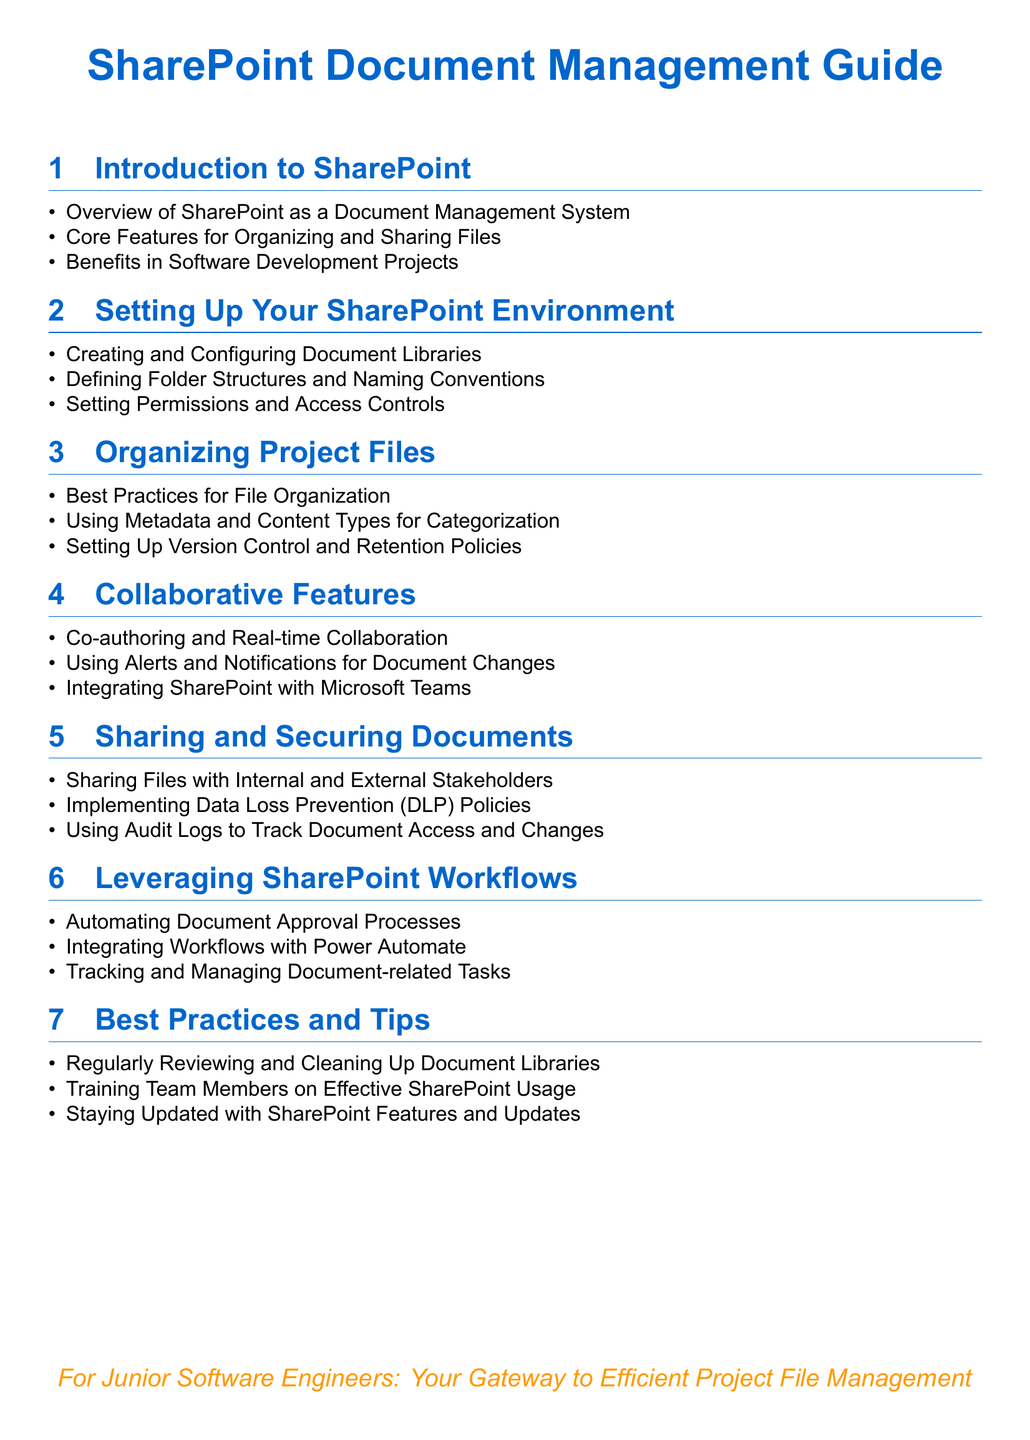What is the title of the document? The title is a central element and provides the subject of the document focused on SharePoint document management.
Answer: SharePoint Document Management Guide What is the core feature for organizing files? The document lists "Core Features for Organizing and Sharing Files" as a key point in the introduction section.
Answer: Core Features for Organizing and Sharing Files What is one benefit of SharePoint in software development projects? The introduction section highlights the advantages SharePoint brings specifically to software development projects.
Answer: Benefits in Software Development Projects What practice is recommended for file organization? The document provides guidance on best practices within the section dedicated to organizing project files.
Answer: Best Practices for File Organization Which tool can be integrated with SharePoint for automated workflows? The document mentions a specific tool that enhances workflow automation in the SharePoint workflow section.
Answer: Power Automate What is the purpose of implementing Data Loss Prevention policies? The document emphasizes the importance of security measures to protect data sharing with stakeholders.
Answer: Securing Documents What should be regularly reviewed and cleaned in SharePoint? The best practices section advises on maintaining the organization of project files and data.
Answer: Document Libraries What is the color used for section titles? The document's design choices, like the color scheme, impact visual information and readability.
Answer: Maincolor What collaborative feature allows real-time document editing? The document outlines features that enhance collaboration among users working on files together.
Answer: Co-authoring 